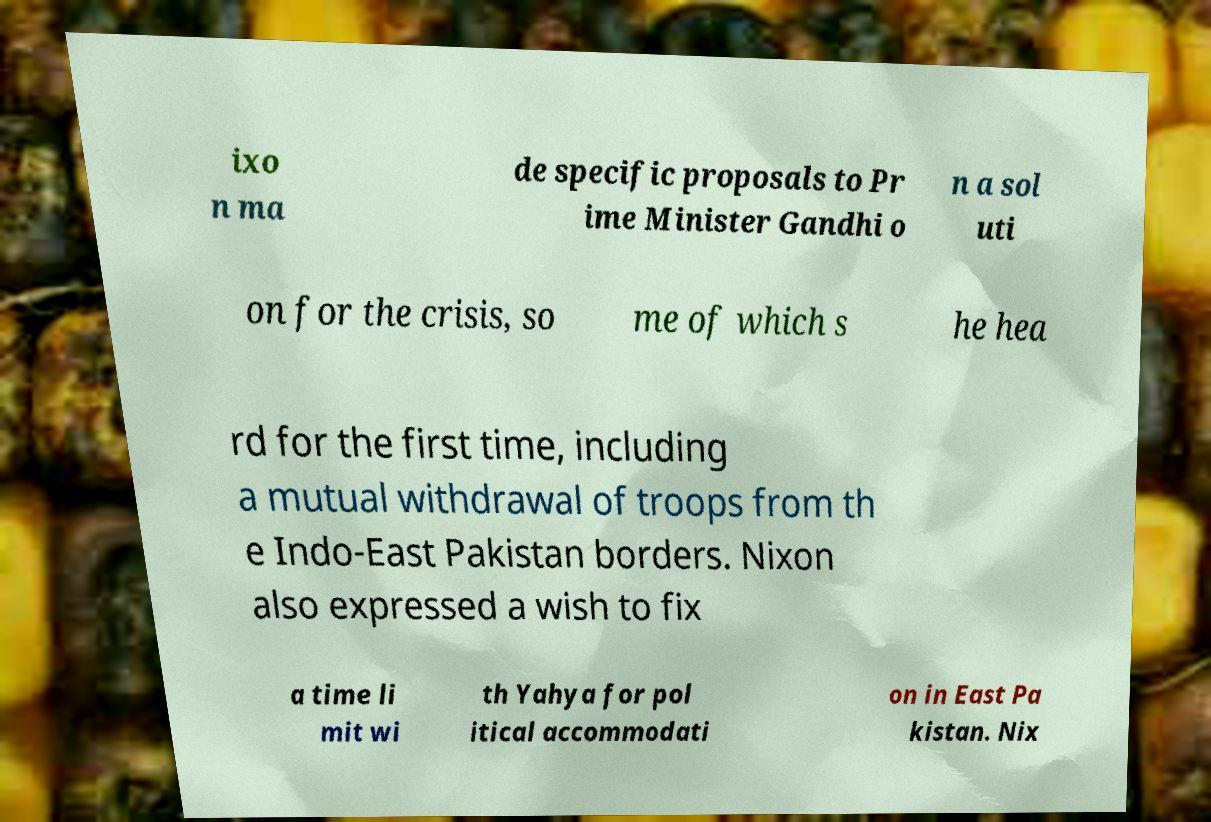Could you extract and type out the text from this image? ixo n ma de specific proposals to Pr ime Minister Gandhi o n a sol uti on for the crisis, so me of which s he hea rd for the first time, including a mutual withdrawal of troops from th e Indo-East Pakistan borders. Nixon also expressed a wish to fix a time li mit wi th Yahya for pol itical accommodati on in East Pa kistan. Nix 